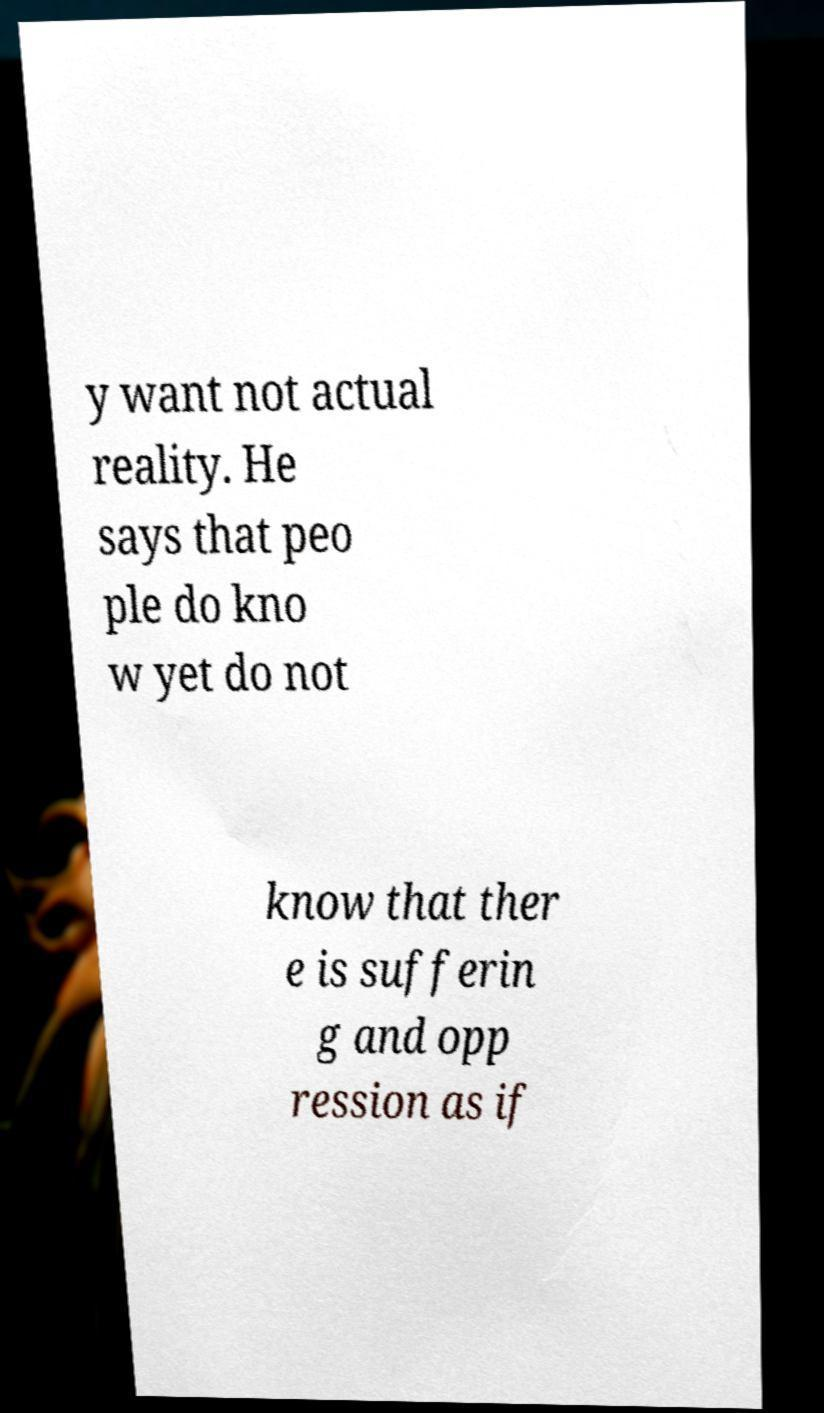Could you assist in decoding the text presented in this image and type it out clearly? y want not actual reality. He says that peo ple do kno w yet do not know that ther e is sufferin g and opp ression as if 